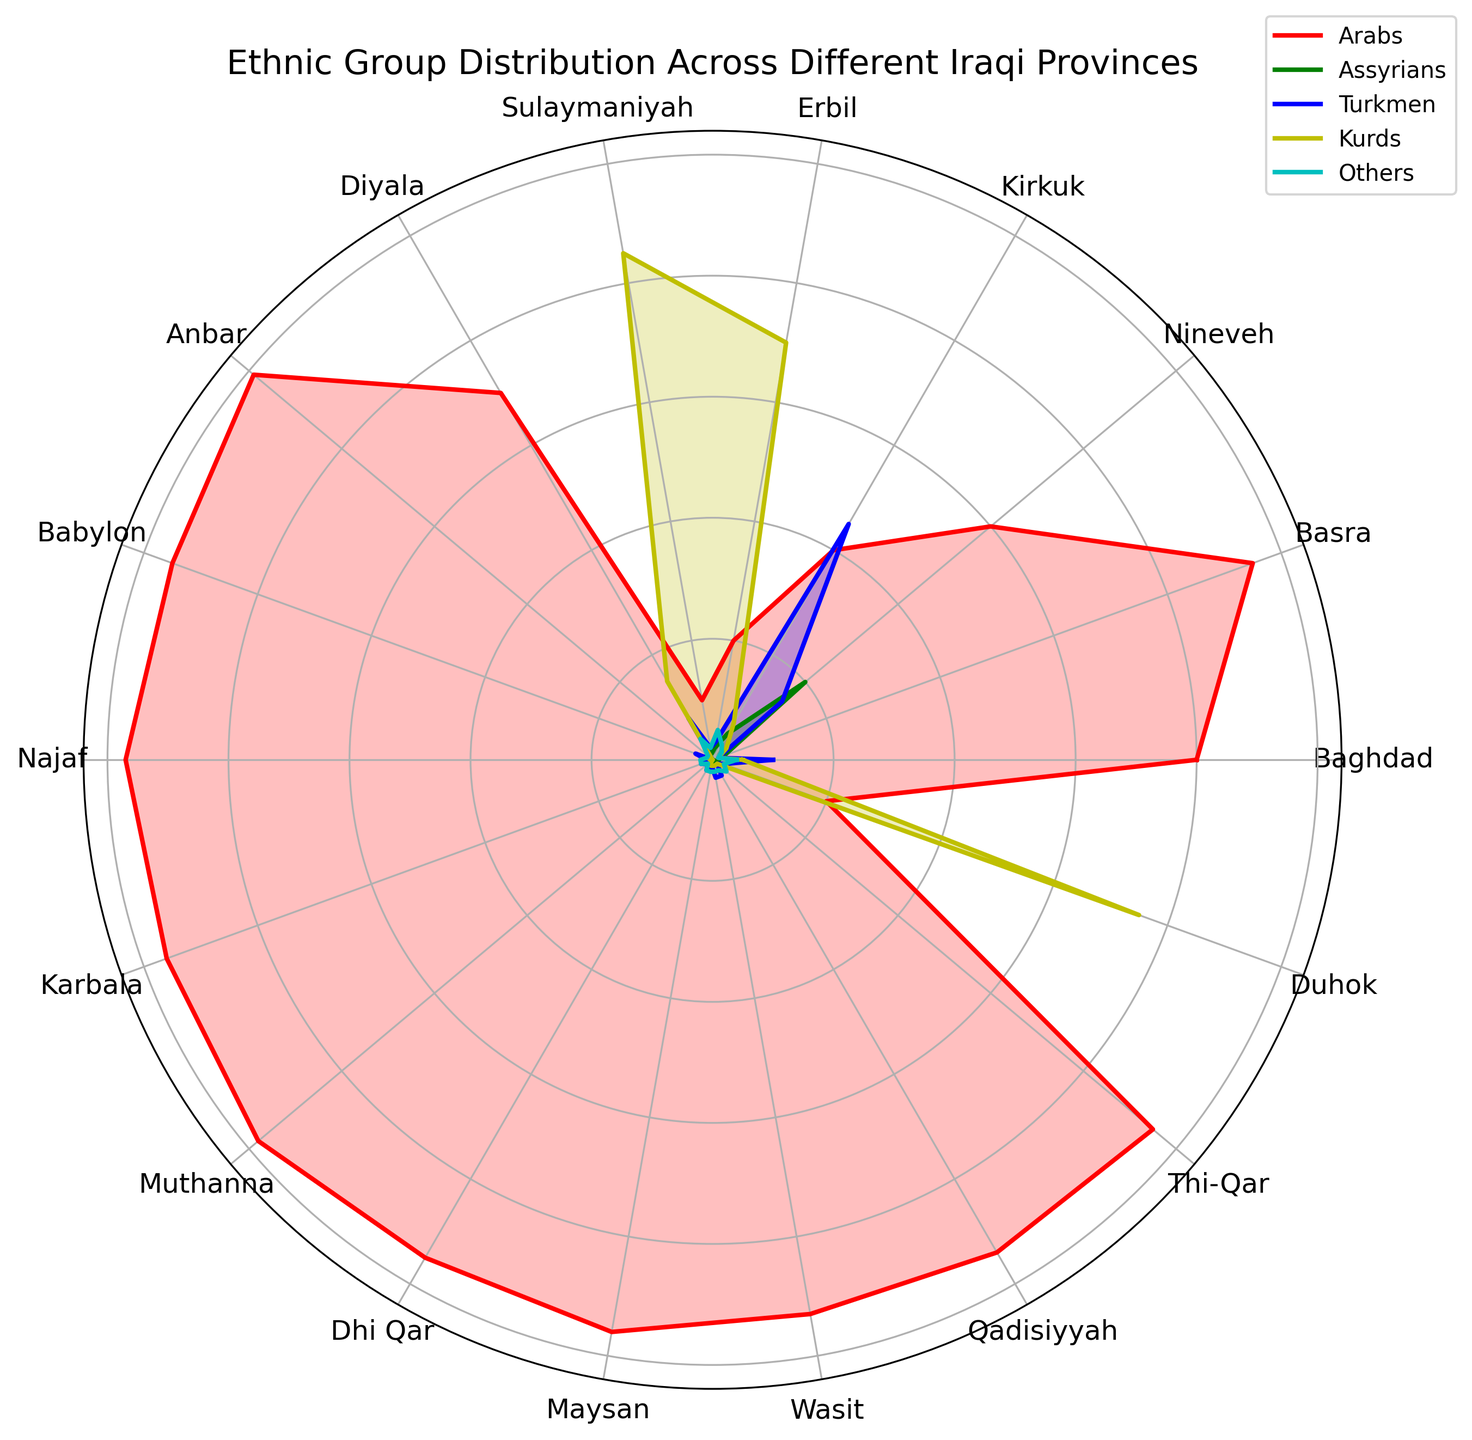Which province has the highest percentage of Kurds? The visual shows that the yellow section representing Kurds extends the farthest in Erbil.
Answer: Erbil Which province has the highest percentage of Arabs? The red section representing Arabs extends the farthest in Anbar.
Answer: Anbar Which two provinces have a notable presence of Assyrians? The figure shows significant green sections for Nineveh and Baghdad.
Answer: Nineveh and Baghdad Which ethnic group dominates the province of Basra? The red section, representing Arabs, occupies almost the entire circumference for Basra.
Answer: Arabs Compare the presence of Kurds in Duhok and Sulaymaniyah. Which province has a higher percentage? The yellow section in Sulaymaniyah is larger than in Duhok, indicating a higher percentage of Kurds in Sulaymaniyah.
Answer: Sulaymaniyah How does the percentage of Turkmen in Kirkuk compare to that in Diyala? The blue section in Kirkuk is much larger compared to Diyala, indicating a higher percentage of Turkmen in Kirkuk.
Answer: Kirkuk Which province has the most diverse ethnic distribution? The province with significant sections of different colors is Nineveh, indicating a more diverse ethnic distribution.
Answer: Nineveh What is the combined percentage of Assyrians and Kurds in Nineveh? From the visual, Assyrians (green) are 20% and Kurds (yellow) are 3%. Therefore, 20% + 3% = 23%.
Answer: 23% In how many provinces do Arabs constitute more than 90%? Observing the lengths of the red sections, Arabs constitute more than 90% in Baghdad, Basra, Anbar, Babylon, Najaf, Karbala, Muthanna, Dhi Qar, Maysan, Wasit, Qadisiyyah, and Thi-Qar, making it 12 provinces.
Answer: 12 Are there any provinces where the 'Others' ethnic group forms a prominent part? The cyan-colored sections are generally small across all provinces, indicating 'Others' don’t prominently feature in any province.
Answer: No 